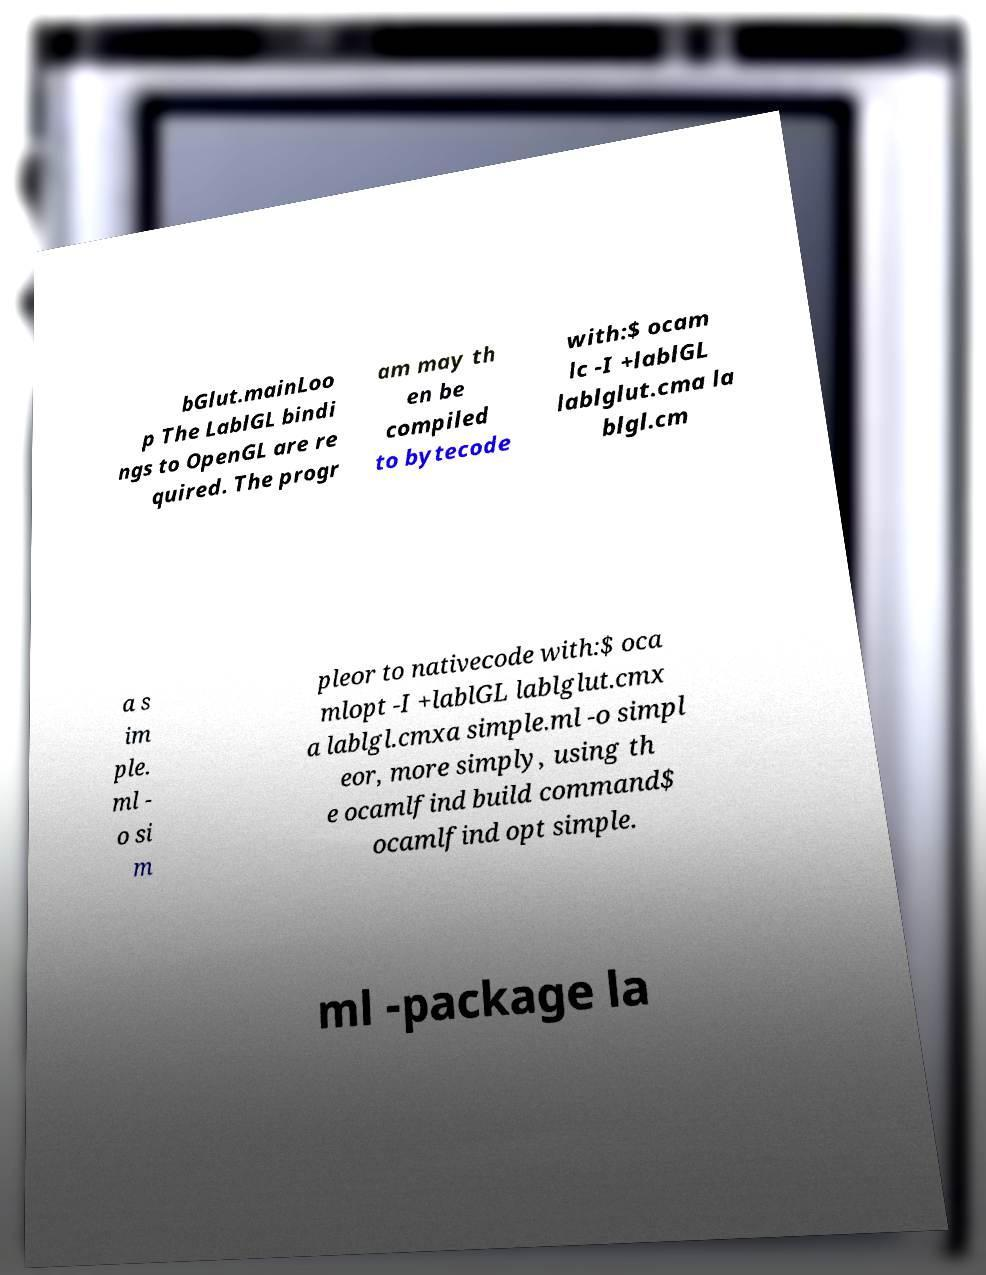Could you assist in decoding the text presented in this image and type it out clearly? bGlut.mainLoo p The LablGL bindi ngs to OpenGL are re quired. The progr am may th en be compiled to bytecode with:$ ocam lc -I +lablGL lablglut.cma la blgl.cm a s im ple. ml - o si m pleor to nativecode with:$ oca mlopt -I +lablGL lablglut.cmx a lablgl.cmxa simple.ml -o simpl eor, more simply, using th e ocamlfind build command$ ocamlfind opt simple. ml -package la 